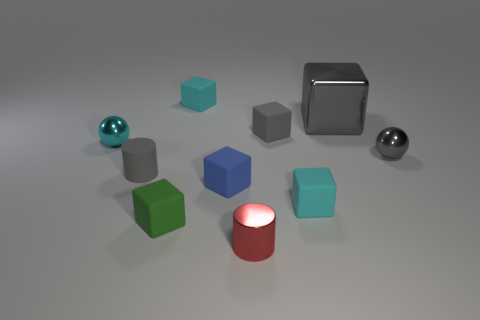Is there any other thing that is the same size as the gray metallic block?
Your response must be concise. No. There is a cyan thing that is both in front of the gray shiny block and on the left side of the blue matte thing; what size is it?
Your answer should be very brief. Small. Is the number of red metal objects that are in front of the cyan shiny object less than the number of gray matte things behind the red cylinder?
Your answer should be compact. Yes. Do the cyan sphere on the left side of the small gray matte block and the small cyan block that is behind the tiny gray block have the same material?
Give a very brief answer. No. What material is the cylinder that is the same color as the big metal cube?
Provide a succinct answer. Rubber. There is a small metallic object that is behind the green block and on the left side of the big gray metal cube; what shape is it?
Offer a terse response. Sphere. There is a small block to the left of the cyan matte object that is behind the large gray thing; what is it made of?
Provide a short and direct response. Rubber. Are there more tiny cyan metal balls than balls?
Your answer should be very brief. No. Do the large thing and the tiny shiny cylinder have the same color?
Provide a short and direct response. No. There is another ball that is the same size as the gray shiny sphere; what material is it?
Your response must be concise. Metal. 